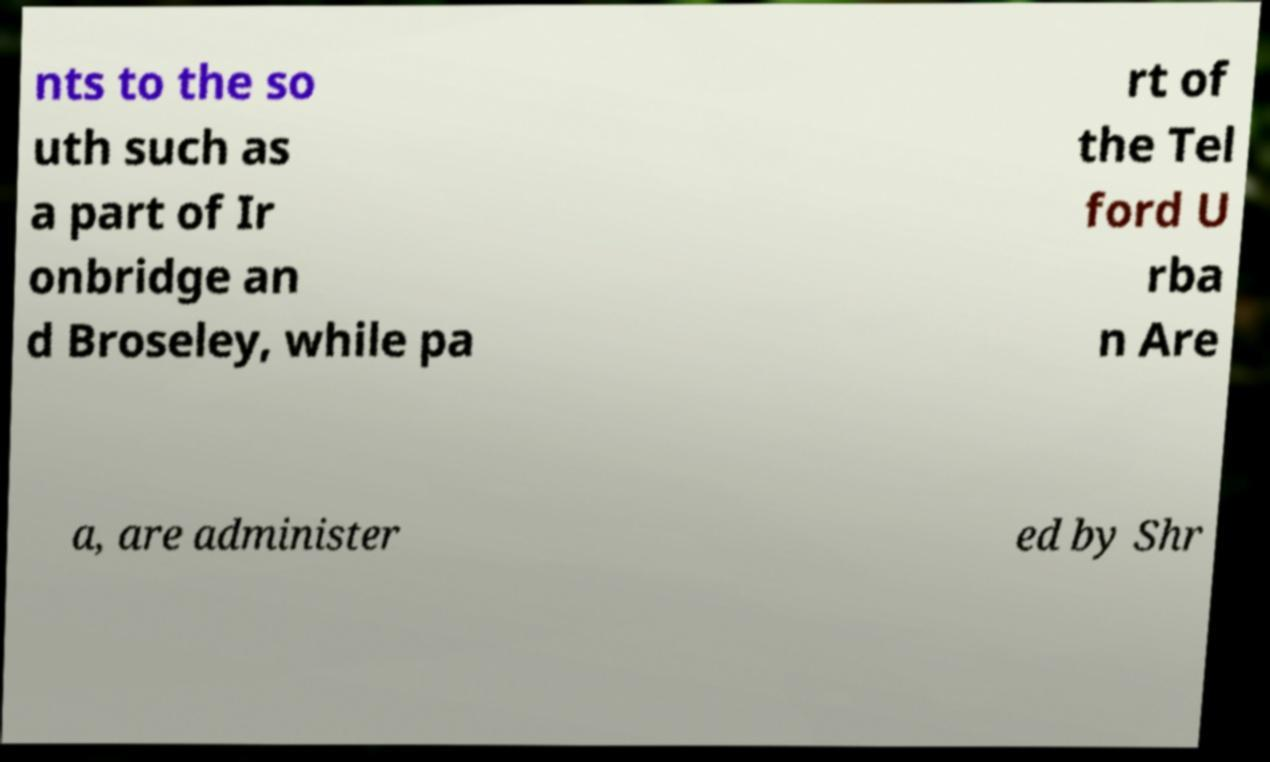Can you read and provide the text displayed in the image?This photo seems to have some interesting text. Can you extract and type it out for me? nts to the so uth such as a part of Ir onbridge an d Broseley, while pa rt of the Tel ford U rba n Are a, are administer ed by Shr 